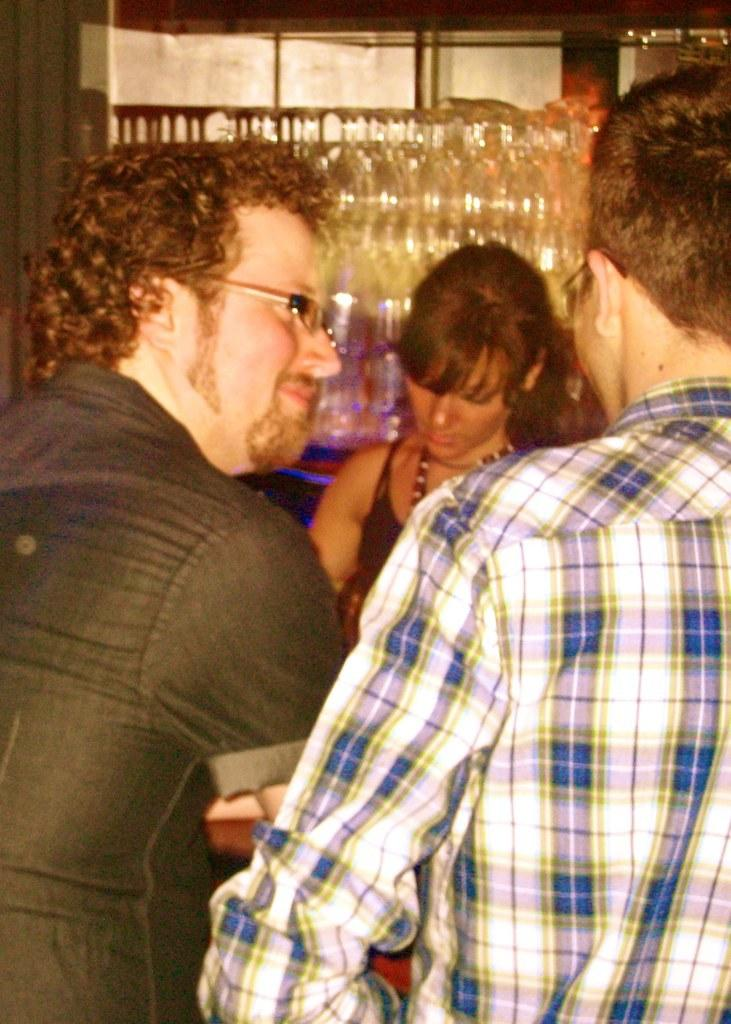How many people are in the image? There is a group of persons in the image. Can you describe the man on the left side of the image? The man on the left side of the image is smiling. What can be seen in the background of the image? There is a woman in the background of the image. What objects are visible behind the woman in the background? There are glasses visible behind the woman in the background. What type of nail is being hammered by the man in the image? There is no nail being hammered in the image; the man on the left side of the image is smiling. 